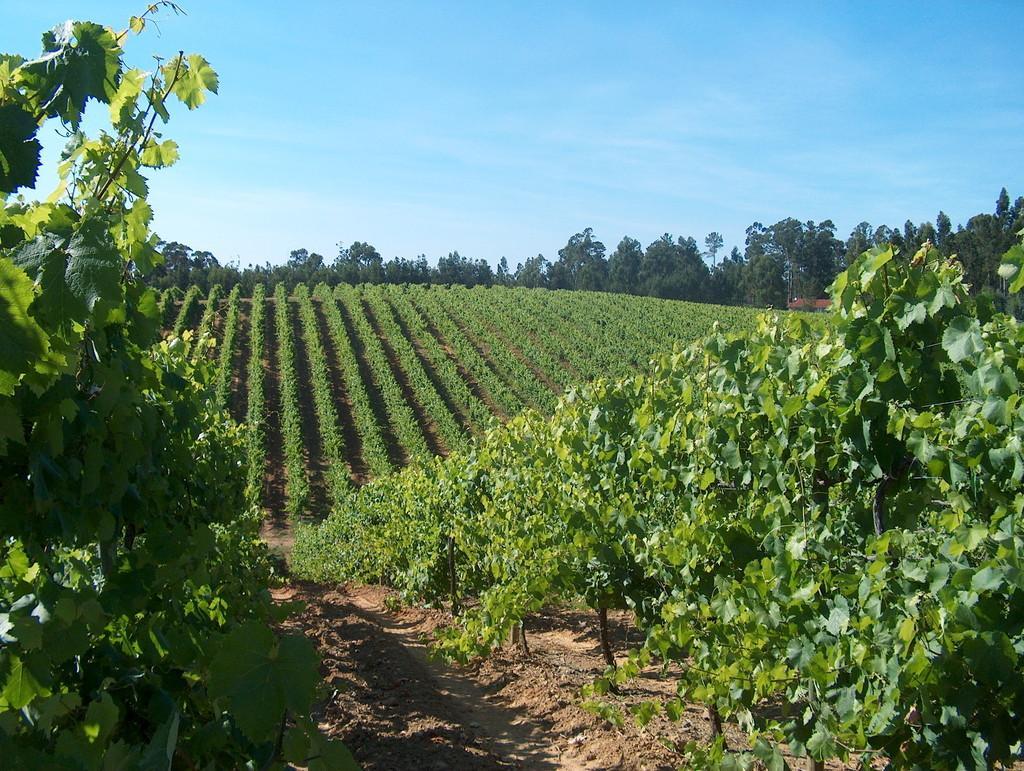How would you summarize this image in a sentence or two? In this picture there is greenery in the image and there is a path at the bottom side of the image. 